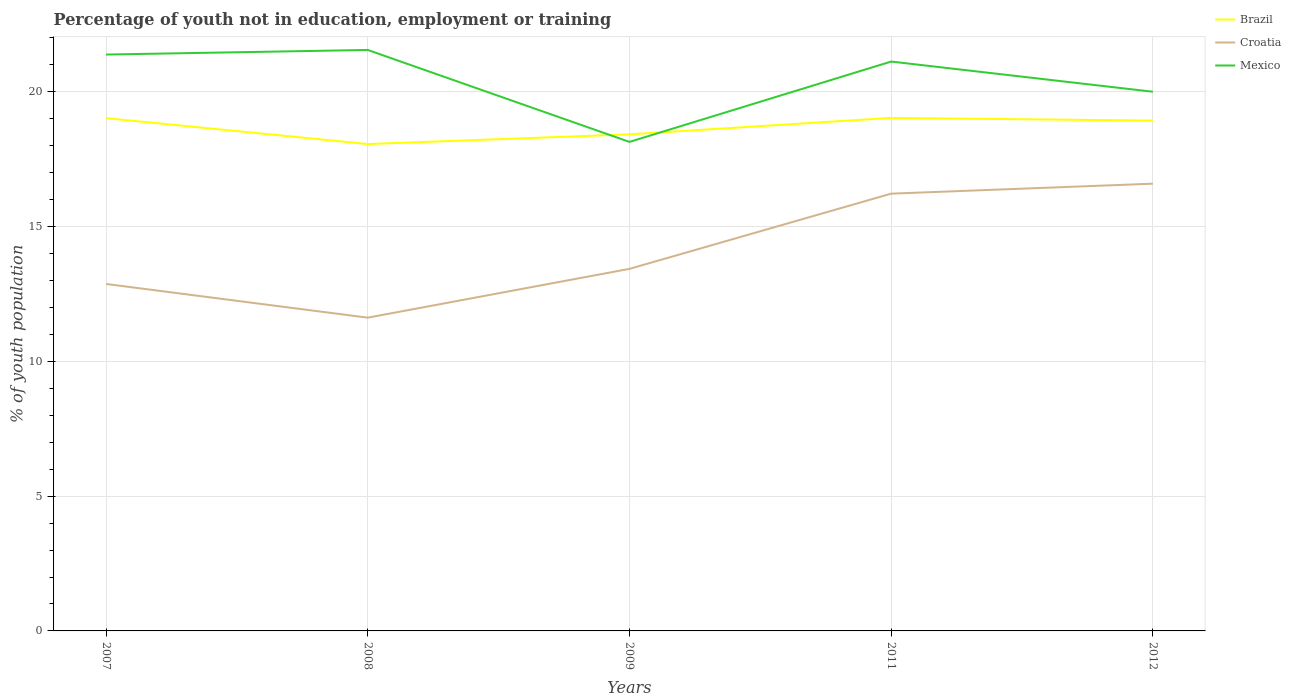How many different coloured lines are there?
Your response must be concise. 3. Does the line corresponding to Croatia intersect with the line corresponding to Mexico?
Give a very brief answer. No. Is the number of lines equal to the number of legend labels?
Your answer should be very brief. Yes. Across all years, what is the maximum percentage of unemployed youth population in in Brazil?
Ensure brevity in your answer.  18.06. In which year was the percentage of unemployed youth population in in Mexico maximum?
Make the answer very short. 2009. What is the total percentage of unemployed youth population in in Brazil in the graph?
Offer a terse response. -0.51. What is the difference between the highest and the second highest percentage of unemployed youth population in in Mexico?
Keep it short and to the point. 3.41. What is the difference between the highest and the lowest percentage of unemployed youth population in in Mexico?
Offer a very short reply. 3. Is the percentage of unemployed youth population in in Croatia strictly greater than the percentage of unemployed youth population in in Mexico over the years?
Give a very brief answer. Yes. How many years are there in the graph?
Give a very brief answer. 5. What is the difference between two consecutive major ticks on the Y-axis?
Offer a terse response. 5. Are the values on the major ticks of Y-axis written in scientific E-notation?
Make the answer very short. No. How are the legend labels stacked?
Offer a very short reply. Vertical. What is the title of the graph?
Give a very brief answer. Percentage of youth not in education, employment or training. What is the label or title of the Y-axis?
Offer a very short reply. % of youth population. What is the % of youth population in Brazil in 2007?
Your answer should be very brief. 19.02. What is the % of youth population of Croatia in 2007?
Give a very brief answer. 12.87. What is the % of youth population in Mexico in 2007?
Keep it short and to the point. 21.38. What is the % of youth population of Brazil in 2008?
Ensure brevity in your answer.  18.06. What is the % of youth population of Croatia in 2008?
Give a very brief answer. 11.62. What is the % of youth population of Mexico in 2008?
Offer a very short reply. 21.55. What is the % of youth population in Brazil in 2009?
Your answer should be compact. 18.42. What is the % of youth population of Croatia in 2009?
Offer a terse response. 13.43. What is the % of youth population of Mexico in 2009?
Offer a very short reply. 18.14. What is the % of youth population in Brazil in 2011?
Give a very brief answer. 19.03. What is the % of youth population in Croatia in 2011?
Ensure brevity in your answer.  16.22. What is the % of youth population in Mexico in 2011?
Offer a terse response. 21.12. What is the % of youth population of Brazil in 2012?
Provide a succinct answer. 18.93. What is the % of youth population of Croatia in 2012?
Ensure brevity in your answer.  16.59. Across all years, what is the maximum % of youth population in Brazil?
Your answer should be compact. 19.03. Across all years, what is the maximum % of youth population in Croatia?
Your answer should be very brief. 16.59. Across all years, what is the maximum % of youth population in Mexico?
Keep it short and to the point. 21.55. Across all years, what is the minimum % of youth population of Brazil?
Offer a terse response. 18.06. Across all years, what is the minimum % of youth population in Croatia?
Make the answer very short. 11.62. Across all years, what is the minimum % of youth population in Mexico?
Offer a terse response. 18.14. What is the total % of youth population of Brazil in the graph?
Your answer should be very brief. 93.46. What is the total % of youth population in Croatia in the graph?
Offer a terse response. 70.73. What is the total % of youth population of Mexico in the graph?
Offer a very short reply. 102.19. What is the difference between the % of youth population of Croatia in 2007 and that in 2008?
Your response must be concise. 1.25. What is the difference between the % of youth population of Mexico in 2007 and that in 2008?
Ensure brevity in your answer.  -0.17. What is the difference between the % of youth population in Brazil in 2007 and that in 2009?
Keep it short and to the point. 0.6. What is the difference between the % of youth population of Croatia in 2007 and that in 2009?
Your answer should be very brief. -0.56. What is the difference between the % of youth population of Mexico in 2007 and that in 2009?
Ensure brevity in your answer.  3.24. What is the difference between the % of youth population of Brazil in 2007 and that in 2011?
Your answer should be compact. -0.01. What is the difference between the % of youth population in Croatia in 2007 and that in 2011?
Your answer should be compact. -3.35. What is the difference between the % of youth population in Mexico in 2007 and that in 2011?
Provide a short and direct response. 0.26. What is the difference between the % of youth population in Brazil in 2007 and that in 2012?
Provide a short and direct response. 0.09. What is the difference between the % of youth population of Croatia in 2007 and that in 2012?
Provide a short and direct response. -3.72. What is the difference between the % of youth population in Mexico in 2007 and that in 2012?
Your answer should be very brief. 1.38. What is the difference between the % of youth population in Brazil in 2008 and that in 2009?
Provide a short and direct response. -0.36. What is the difference between the % of youth population of Croatia in 2008 and that in 2009?
Offer a very short reply. -1.81. What is the difference between the % of youth population in Mexico in 2008 and that in 2009?
Offer a terse response. 3.41. What is the difference between the % of youth population of Brazil in 2008 and that in 2011?
Your response must be concise. -0.97. What is the difference between the % of youth population in Croatia in 2008 and that in 2011?
Offer a very short reply. -4.6. What is the difference between the % of youth population of Mexico in 2008 and that in 2011?
Provide a short and direct response. 0.43. What is the difference between the % of youth population of Brazil in 2008 and that in 2012?
Provide a succinct answer. -0.87. What is the difference between the % of youth population of Croatia in 2008 and that in 2012?
Give a very brief answer. -4.97. What is the difference between the % of youth population in Mexico in 2008 and that in 2012?
Offer a very short reply. 1.55. What is the difference between the % of youth population in Brazil in 2009 and that in 2011?
Make the answer very short. -0.61. What is the difference between the % of youth population of Croatia in 2009 and that in 2011?
Make the answer very short. -2.79. What is the difference between the % of youth population of Mexico in 2009 and that in 2011?
Give a very brief answer. -2.98. What is the difference between the % of youth population of Brazil in 2009 and that in 2012?
Provide a short and direct response. -0.51. What is the difference between the % of youth population of Croatia in 2009 and that in 2012?
Provide a short and direct response. -3.16. What is the difference between the % of youth population of Mexico in 2009 and that in 2012?
Your answer should be compact. -1.86. What is the difference between the % of youth population of Brazil in 2011 and that in 2012?
Offer a terse response. 0.1. What is the difference between the % of youth population of Croatia in 2011 and that in 2012?
Provide a short and direct response. -0.37. What is the difference between the % of youth population of Mexico in 2011 and that in 2012?
Your answer should be very brief. 1.12. What is the difference between the % of youth population of Brazil in 2007 and the % of youth population of Mexico in 2008?
Your answer should be compact. -2.53. What is the difference between the % of youth population of Croatia in 2007 and the % of youth population of Mexico in 2008?
Give a very brief answer. -8.68. What is the difference between the % of youth population in Brazil in 2007 and the % of youth population in Croatia in 2009?
Provide a short and direct response. 5.59. What is the difference between the % of youth population in Croatia in 2007 and the % of youth population in Mexico in 2009?
Give a very brief answer. -5.27. What is the difference between the % of youth population of Brazil in 2007 and the % of youth population of Croatia in 2011?
Provide a short and direct response. 2.8. What is the difference between the % of youth population in Brazil in 2007 and the % of youth population in Mexico in 2011?
Provide a succinct answer. -2.1. What is the difference between the % of youth population in Croatia in 2007 and the % of youth population in Mexico in 2011?
Offer a terse response. -8.25. What is the difference between the % of youth population in Brazil in 2007 and the % of youth population in Croatia in 2012?
Ensure brevity in your answer.  2.43. What is the difference between the % of youth population of Brazil in 2007 and the % of youth population of Mexico in 2012?
Make the answer very short. -0.98. What is the difference between the % of youth population of Croatia in 2007 and the % of youth population of Mexico in 2012?
Provide a short and direct response. -7.13. What is the difference between the % of youth population in Brazil in 2008 and the % of youth population in Croatia in 2009?
Make the answer very short. 4.63. What is the difference between the % of youth population of Brazil in 2008 and the % of youth population of Mexico in 2009?
Your answer should be compact. -0.08. What is the difference between the % of youth population in Croatia in 2008 and the % of youth population in Mexico in 2009?
Give a very brief answer. -6.52. What is the difference between the % of youth population in Brazil in 2008 and the % of youth population in Croatia in 2011?
Provide a short and direct response. 1.84. What is the difference between the % of youth population of Brazil in 2008 and the % of youth population of Mexico in 2011?
Provide a short and direct response. -3.06. What is the difference between the % of youth population in Brazil in 2008 and the % of youth population in Croatia in 2012?
Ensure brevity in your answer.  1.47. What is the difference between the % of youth population in Brazil in 2008 and the % of youth population in Mexico in 2012?
Your answer should be compact. -1.94. What is the difference between the % of youth population of Croatia in 2008 and the % of youth population of Mexico in 2012?
Provide a succinct answer. -8.38. What is the difference between the % of youth population in Brazil in 2009 and the % of youth population in Croatia in 2011?
Provide a succinct answer. 2.2. What is the difference between the % of youth population of Croatia in 2009 and the % of youth population of Mexico in 2011?
Your answer should be very brief. -7.69. What is the difference between the % of youth population of Brazil in 2009 and the % of youth population of Croatia in 2012?
Make the answer very short. 1.83. What is the difference between the % of youth population in Brazil in 2009 and the % of youth population in Mexico in 2012?
Keep it short and to the point. -1.58. What is the difference between the % of youth population of Croatia in 2009 and the % of youth population of Mexico in 2012?
Keep it short and to the point. -6.57. What is the difference between the % of youth population in Brazil in 2011 and the % of youth population in Croatia in 2012?
Your response must be concise. 2.44. What is the difference between the % of youth population of Brazil in 2011 and the % of youth population of Mexico in 2012?
Provide a short and direct response. -0.97. What is the difference between the % of youth population in Croatia in 2011 and the % of youth population in Mexico in 2012?
Keep it short and to the point. -3.78. What is the average % of youth population of Brazil per year?
Your answer should be compact. 18.69. What is the average % of youth population of Croatia per year?
Your answer should be compact. 14.15. What is the average % of youth population in Mexico per year?
Offer a terse response. 20.44. In the year 2007, what is the difference between the % of youth population of Brazil and % of youth population of Croatia?
Keep it short and to the point. 6.15. In the year 2007, what is the difference between the % of youth population of Brazil and % of youth population of Mexico?
Provide a succinct answer. -2.36. In the year 2007, what is the difference between the % of youth population of Croatia and % of youth population of Mexico?
Your response must be concise. -8.51. In the year 2008, what is the difference between the % of youth population of Brazil and % of youth population of Croatia?
Provide a succinct answer. 6.44. In the year 2008, what is the difference between the % of youth population in Brazil and % of youth population in Mexico?
Offer a terse response. -3.49. In the year 2008, what is the difference between the % of youth population in Croatia and % of youth population in Mexico?
Your answer should be very brief. -9.93. In the year 2009, what is the difference between the % of youth population of Brazil and % of youth population of Croatia?
Offer a terse response. 4.99. In the year 2009, what is the difference between the % of youth population in Brazil and % of youth population in Mexico?
Offer a very short reply. 0.28. In the year 2009, what is the difference between the % of youth population of Croatia and % of youth population of Mexico?
Your response must be concise. -4.71. In the year 2011, what is the difference between the % of youth population in Brazil and % of youth population in Croatia?
Your answer should be very brief. 2.81. In the year 2011, what is the difference between the % of youth population of Brazil and % of youth population of Mexico?
Offer a very short reply. -2.09. In the year 2011, what is the difference between the % of youth population of Croatia and % of youth population of Mexico?
Make the answer very short. -4.9. In the year 2012, what is the difference between the % of youth population of Brazil and % of youth population of Croatia?
Offer a terse response. 2.34. In the year 2012, what is the difference between the % of youth population in Brazil and % of youth population in Mexico?
Provide a succinct answer. -1.07. In the year 2012, what is the difference between the % of youth population of Croatia and % of youth population of Mexico?
Keep it short and to the point. -3.41. What is the ratio of the % of youth population of Brazil in 2007 to that in 2008?
Give a very brief answer. 1.05. What is the ratio of the % of youth population of Croatia in 2007 to that in 2008?
Provide a short and direct response. 1.11. What is the ratio of the % of youth population in Brazil in 2007 to that in 2009?
Offer a terse response. 1.03. What is the ratio of the % of youth population of Mexico in 2007 to that in 2009?
Your response must be concise. 1.18. What is the ratio of the % of youth population of Brazil in 2007 to that in 2011?
Keep it short and to the point. 1. What is the ratio of the % of youth population of Croatia in 2007 to that in 2011?
Ensure brevity in your answer.  0.79. What is the ratio of the % of youth population in Mexico in 2007 to that in 2011?
Offer a very short reply. 1.01. What is the ratio of the % of youth population of Croatia in 2007 to that in 2012?
Offer a very short reply. 0.78. What is the ratio of the % of youth population of Mexico in 2007 to that in 2012?
Your answer should be very brief. 1.07. What is the ratio of the % of youth population of Brazil in 2008 to that in 2009?
Provide a succinct answer. 0.98. What is the ratio of the % of youth population in Croatia in 2008 to that in 2009?
Make the answer very short. 0.87. What is the ratio of the % of youth population of Mexico in 2008 to that in 2009?
Make the answer very short. 1.19. What is the ratio of the % of youth population of Brazil in 2008 to that in 2011?
Make the answer very short. 0.95. What is the ratio of the % of youth population of Croatia in 2008 to that in 2011?
Your answer should be compact. 0.72. What is the ratio of the % of youth population in Mexico in 2008 to that in 2011?
Keep it short and to the point. 1.02. What is the ratio of the % of youth population of Brazil in 2008 to that in 2012?
Offer a very short reply. 0.95. What is the ratio of the % of youth population in Croatia in 2008 to that in 2012?
Ensure brevity in your answer.  0.7. What is the ratio of the % of youth population in Mexico in 2008 to that in 2012?
Offer a very short reply. 1.08. What is the ratio of the % of youth population of Brazil in 2009 to that in 2011?
Provide a short and direct response. 0.97. What is the ratio of the % of youth population in Croatia in 2009 to that in 2011?
Make the answer very short. 0.83. What is the ratio of the % of youth population in Mexico in 2009 to that in 2011?
Offer a very short reply. 0.86. What is the ratio of the % of youth population in Brazil in 2009 to that in 2012?
Make the answer very short. 0.97. What is the ratio of the % of youth population in Croatia in 2009 to that in 2012?
Make the answer very short. 0.81. What is the ratio of the % of youth population of Mexico in 2009 to that in 2012?
Keep it short and to the point. 0.91. What is the ratio of the % of youth population of Brazil in 2011 to that in 2012?
Offer a very short reply. 1.01. What is the ratio of the % of youth population of Croatia in 2011 to that in 2012?
Provide a short and direct response. 0.98. What is the ratio of the % of youth population of Mexico in 2011 to that in 2012?
Your response must be concise. 1.06. What is the difference between the highest and the second highest % of youth population in Croatia?
Ensure brevity in your answer.  0.37. What is the difference between the highest and the second highest % of youth population of Mexico?
Offer a terse response. 0.17. What is the difference between the highest and the lowest % of youth population of Croatia?
Offer a terse response. 4.97. What is the difference between the highest and the lowest % of youth population of Mexico?
Keep it short and to the point. 3.41. 